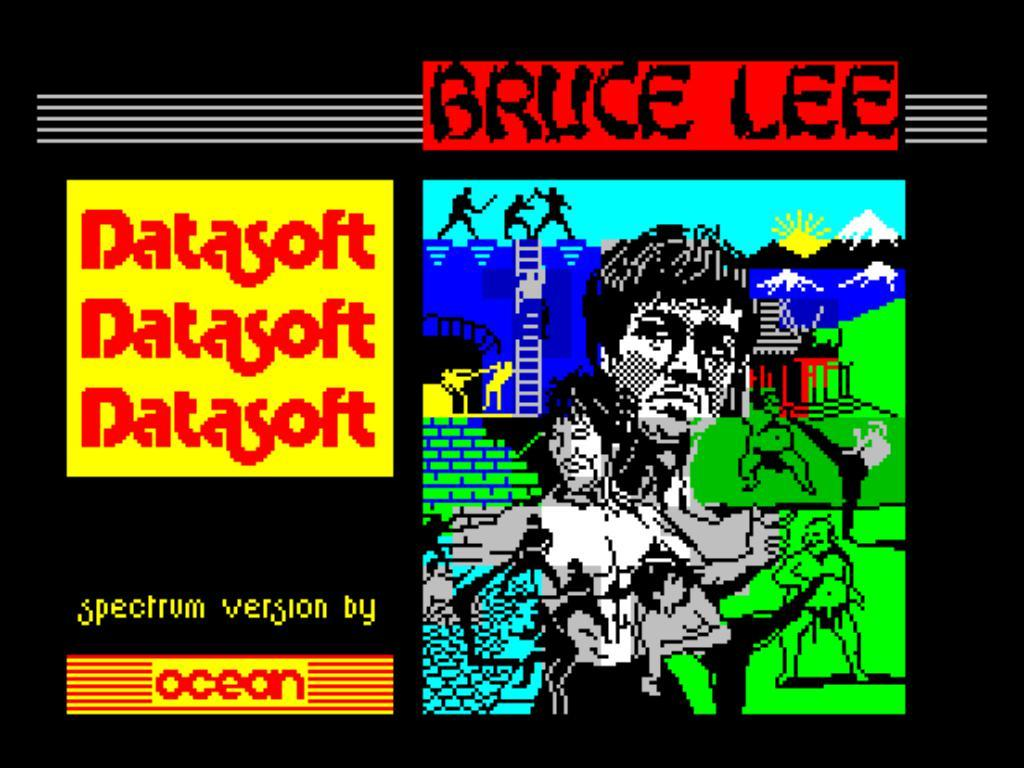<image>
Relay a brief, clear account of the picture shown. A poster of a Bruce Lee picture with Datasoft advertised next to it. 